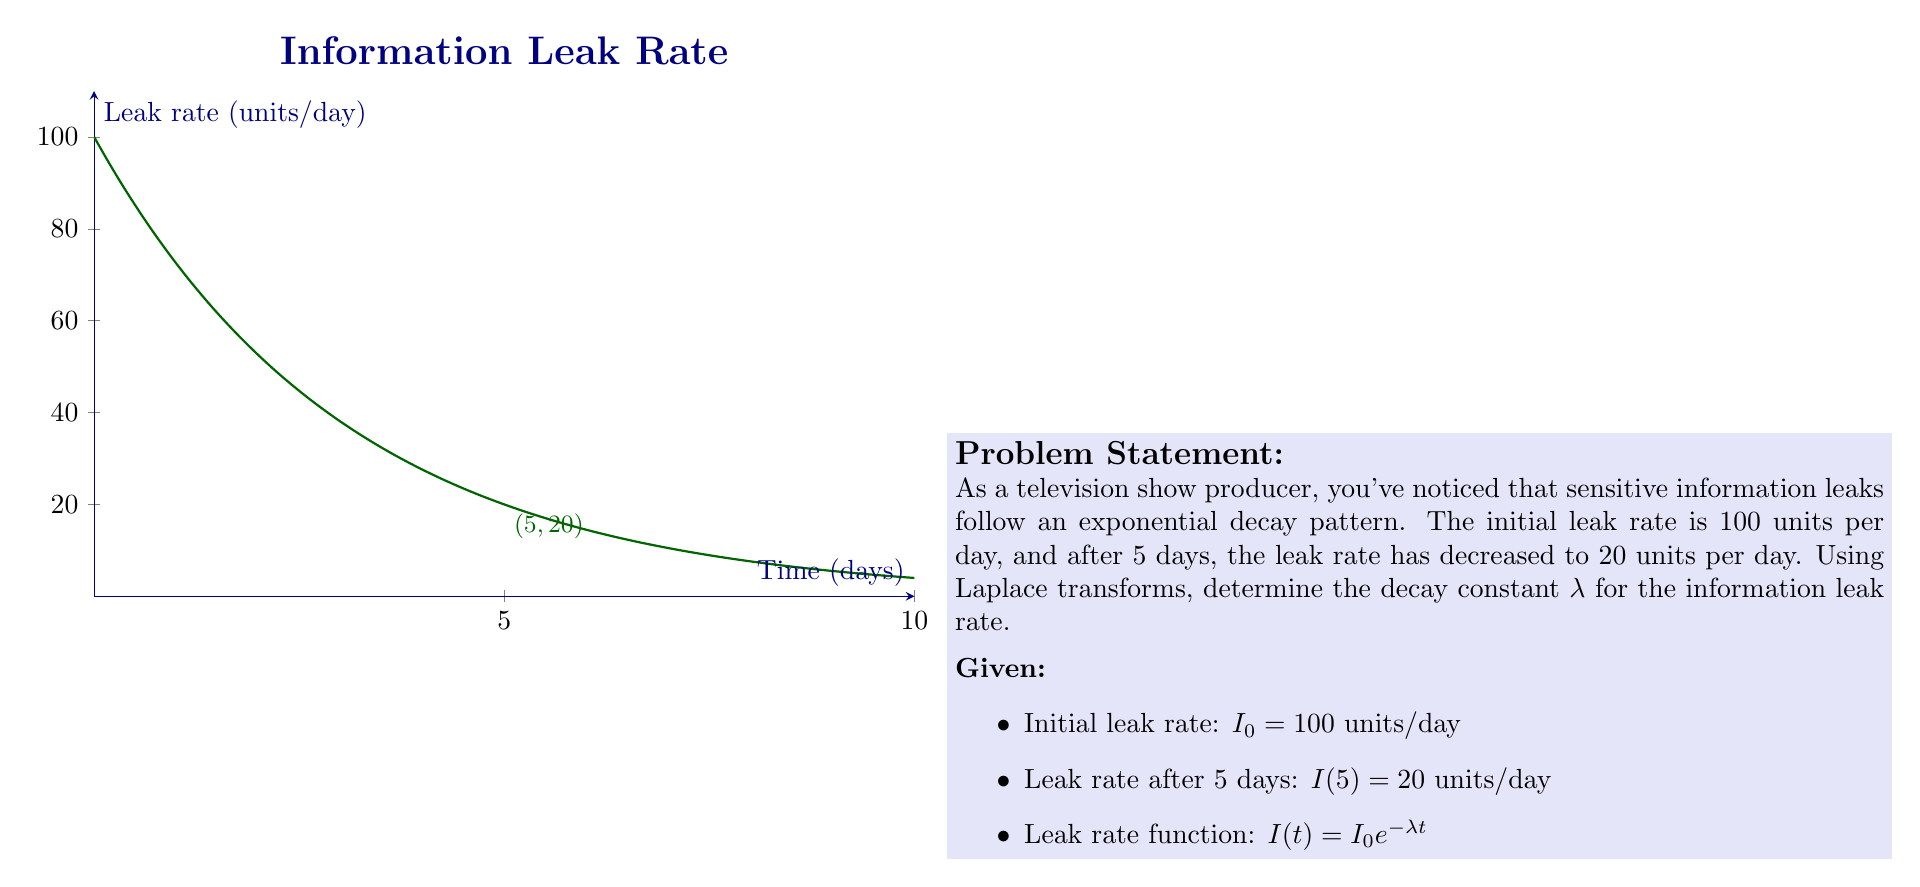What is the answer to this math problem? Let's solve this step-by-step using Laplace transforms:

1) The leak rate function is given by:
   $I(t) = I_0 e^{-λt}$

2) We know that $I(5) = 20$, so we can write:
   $20 = 100 e^{-5λ}$

3) Dividing both sides by 100:
   $\frac{1}{5} = e^{-5λ}$

4) Taking the natural logarithm of both sides:
   $\ln(\frac{1}{5}) = -5λ$

5) Solving for λ:
   $λ = -\frac{1}{5}\ln(\frac{1}{5})$

6) Calculate the value:
   $λ = -\frac{1}{5}\ln(0.2) \approx 0.32189$

7) To verify using Laplace transforms:
   $\mathcal{L}\{I(t)\} = \mathcal{L}\{100e^{-λt}\} = \frac{100}{s+λ}$

8) The inverse Laplace transform gives us back the original function:
   $\mathcal{L}^{-1}\{\frac{100}{s+λ}\} = 100e^{-λt}$

This confirms that our solution is correct in the context of Laplace transforms.
Answer: $λ \approx 0.32189$ day$^{-1}$ 